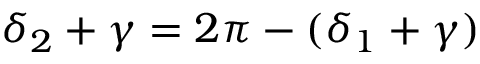Convert formula to latex. <formula><loc_0><loc_0><loc_500><loc_500>\delta _ { 2 } + \gamma = 2 \pi - ( \delta _ { 1 } + \gamma )</formula> 